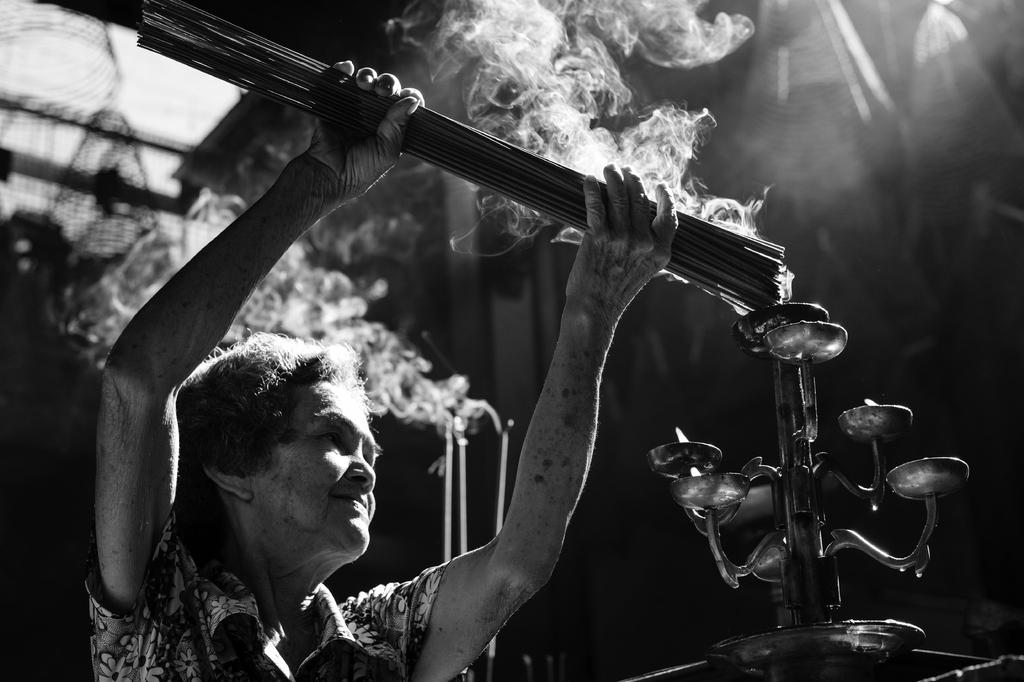What is the main subject of the image? The main subject of the image is a black and white picture of a woman. What is the woman wearing in the image? The woman is wearing clothes in the image. What is the woman holding in the image? The woman is holding sticks in the image. What can be seen near the sticks in the image? There is a flame and smoke visible in the image. What type of object can be seen in the image? There is a metal object in the image. How would you describe the overall appearance of the image? The background of the image is dark. How many visitors can be seen in the image? There are no visitors present in the image; it only features a black and white picture of a woman. What type of wrist accessory is the woman wearing in the image? There is no wrist accessory visible in the image. What is the cause of the fog in the image? There is no fog present in the image. 